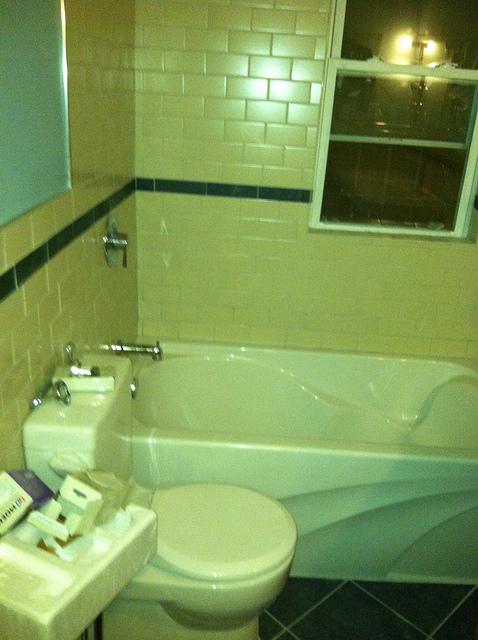Is the toilet lid down?
Short answer required. Yes. What room is this?
Short answer required. Bathroom. Is the window up or down?
Short answer required. Down. 